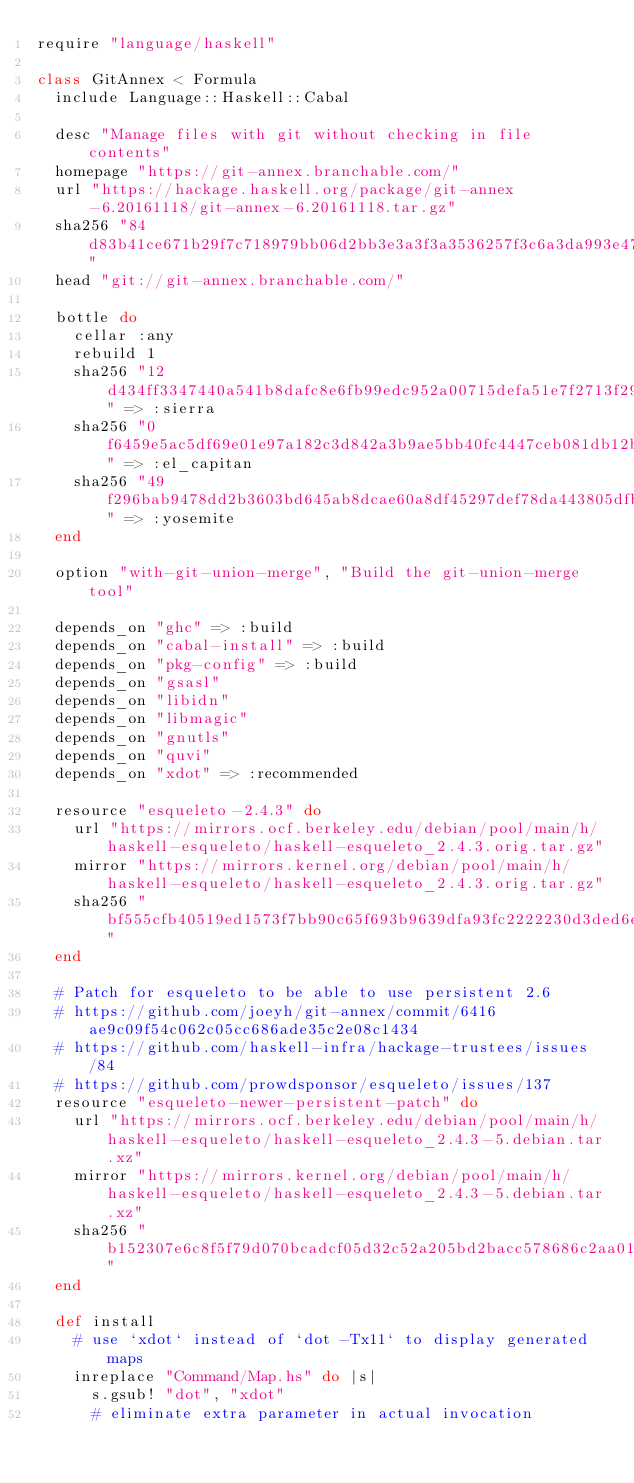<code> <loc_0><loc_0><loc_500><loc_500><_Ruby_>require "language/haskell"

class GitAnnex < Formula
  include Language::Haskell::Cabal

  desc "Manage files with git without checking in file contents"
  homepage "https://git-annex.branchable.com/"
  url "https://hackage.haskell.org/package/git-annex-6.20161118/git-annex-6.20161118.tar.gz"
  sha256 "84d83b41ce671b29f7c718979bb06d2bb3e3a3f3a3536257f3c6a3da993e47ba"
  head "git://git-annex.branchable.com/"

  bottle do
    cellar :any
    rebuild 1
    sha256 "12d434ff3347440a541b8dafc8e6fb99edc952a00715defa51e7f2713f29c9b9" => :sierra
    sha256 "0f6459e5ac5df69e01e97a182c3d842a3b9ae5bb40fc4447ceb081db12b73723" => :el_capitan
    sha256 "49f296bab9478dd2b3603bd645ab8dcae60a8df45297def78da443805dfba086" => :yosemite
  end

  option "with-git-union-merge", "Build the git-union-merge tool"

  depends_on "ghc" => :build
  depends_on "cabal-install" => :build
  depends_on "pkg-config" => :build
  depends_on "gsasl"
  depends_on "libidn"
  depends_on "libmagic"
  depends_on "gnutls"
  depends_on "quvi"
  depends_on "xdot" => :recommended

  resource "esqueleto-2.4.3" do
    url "https://mirrors.ocf.berkeley.edu/debian/pool/main/h/haskell-esqueleto/haskell-esqueleto_2.4.3.orig.tar.gz"
    mirror "https://mirrors.kernel.org/debian/pool/main/h/haskell-esqueleto/haskell-esqueleto_2.4.3.orig.tar.gz"
    sha256 "bf555cfb40519ed1573f7bb90c65f693b9639dfa93fc2222230d3ded6e897434"
  end

  # Patch for esqueleto to be able to use persistent 2.6
  # https://github.com/joeyh/git-annex/commit/6416ae9c09f54c062c05cc686ade35c2e08c1434
  # https://github.com/haskell-infra/hackage-trustees/issues/84
  # https://github.com/prowdsponsor/esqueleto/issues/137
  resource "esqueleto-newer-persistent-patch" do
    url "https://mirrors.ocf.berkeley.edu/debian/pool/main/h/haskell-esqueleto/haskell-esqueleto_2.4.3-5.debian.tar.xz"
    mirror "https://mirrors.kernel.org/debian/pool/main/h/haskell-esqueleto/haskell-esqueleto_2.4.3-5.debian.tar.xz"
    sha256 "b152307e6c8f5f79d070bcadcf05d32c52a205bd2bacc578686c2aa01491aff6"
  end

  def install
    # use `xdot` instead of `dot -Tx11` to display generated maps
    inreplace "Command/Map.hs" do |s|
      s.gsub! "dot", "xdot"
      # eliminate extra parameter in actual invocation</code> 